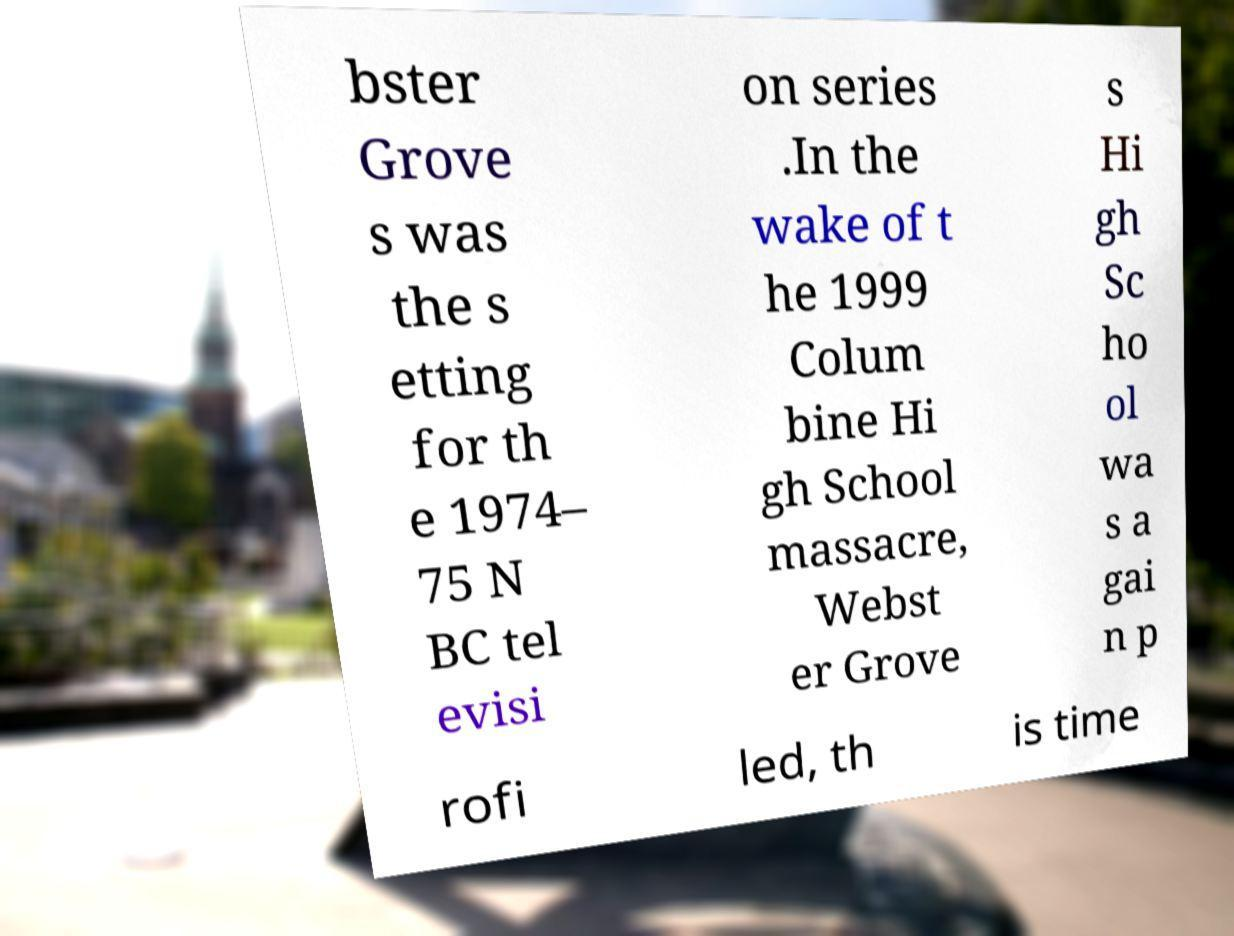Please identify and transcribe the text found in this image. bster Grove s was the s etting for th e 1974– 75 N BC tel evisi on series .In the wake of t he 1999 Colum bine Hi gh School massacre, Webst er Grove s Hi gh Sc ho ol wa s a gai n p rofi led, th is time 